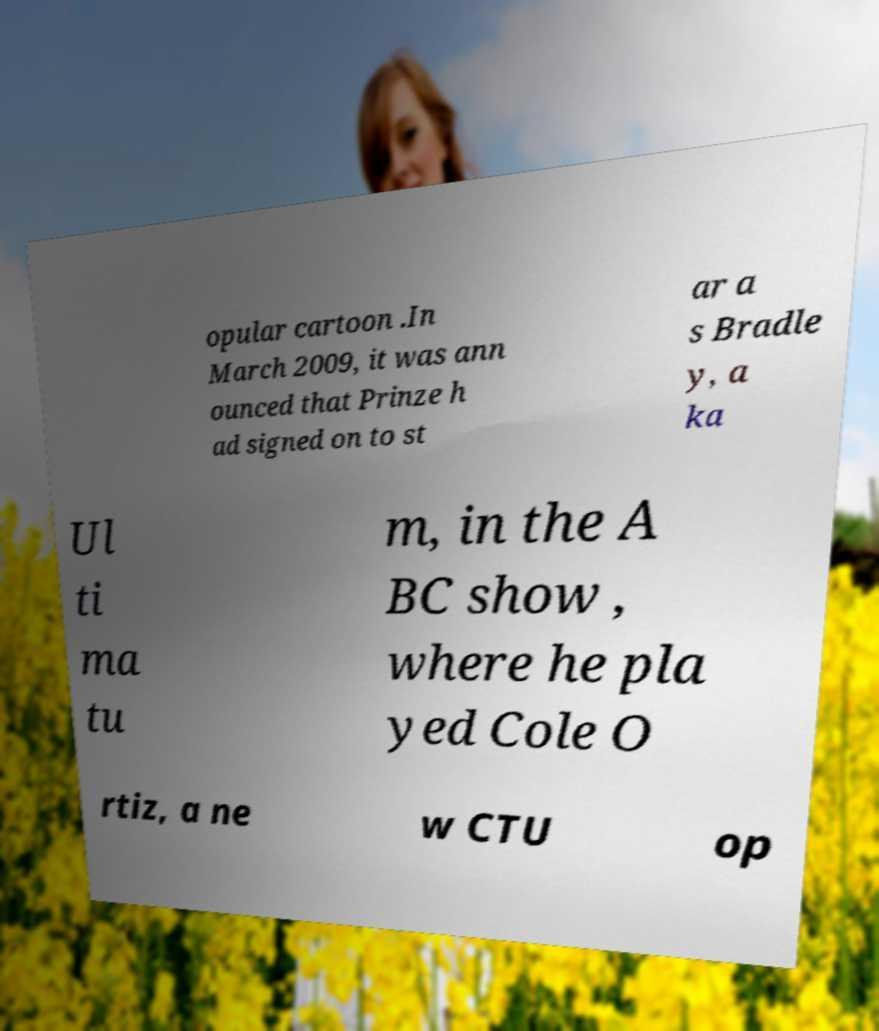For documentation purposes, I need the text within this image transcribed. Could you provide that? opular cartoon .In March 2009, it was ann ounced that Prinze h ad signed on to st ar a s Bradle y, a ka Ul ti ma tu m, in the A BC show , where he pla yed Cole O rtiz, a ne w CTU op 